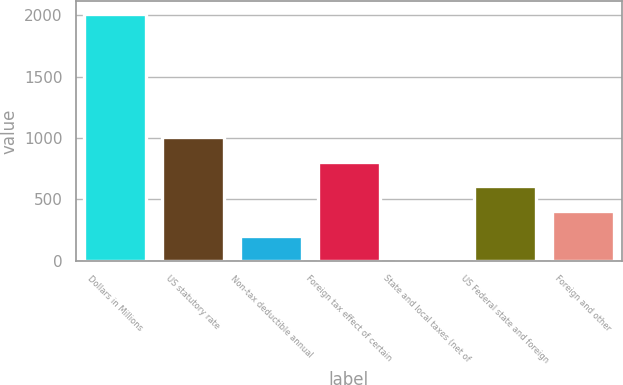Convert chart. <chart><loc_0><loc_0><loc_500><loc_500><bar_chart><fcel>Dollars in Millions<fcel>US statutory rate<fcel>Non-tax deductible annual<fcel>Foreign tax effect of certain<fcel>State and local taxes (net of<fcel>US Federal state and foreign<fcel>Foreign and other<nl><fcel>2013<fcel>1006.95<fcel>202.11<fcel>805.74<fcel>0.9<fcel>604.53<fcel>403.32<nl></chart> 